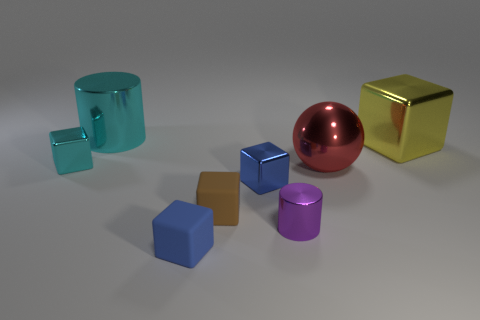What can you infer about the lighting of the scene? The scene is lit with a soft, diffuse light that creates gentle shadows on the ground, indicating an overhead light source, possibly simulating an indoor environment. There are no harsh or direct shadows, suggesting that the lighting is uniform and not strongly directional. 